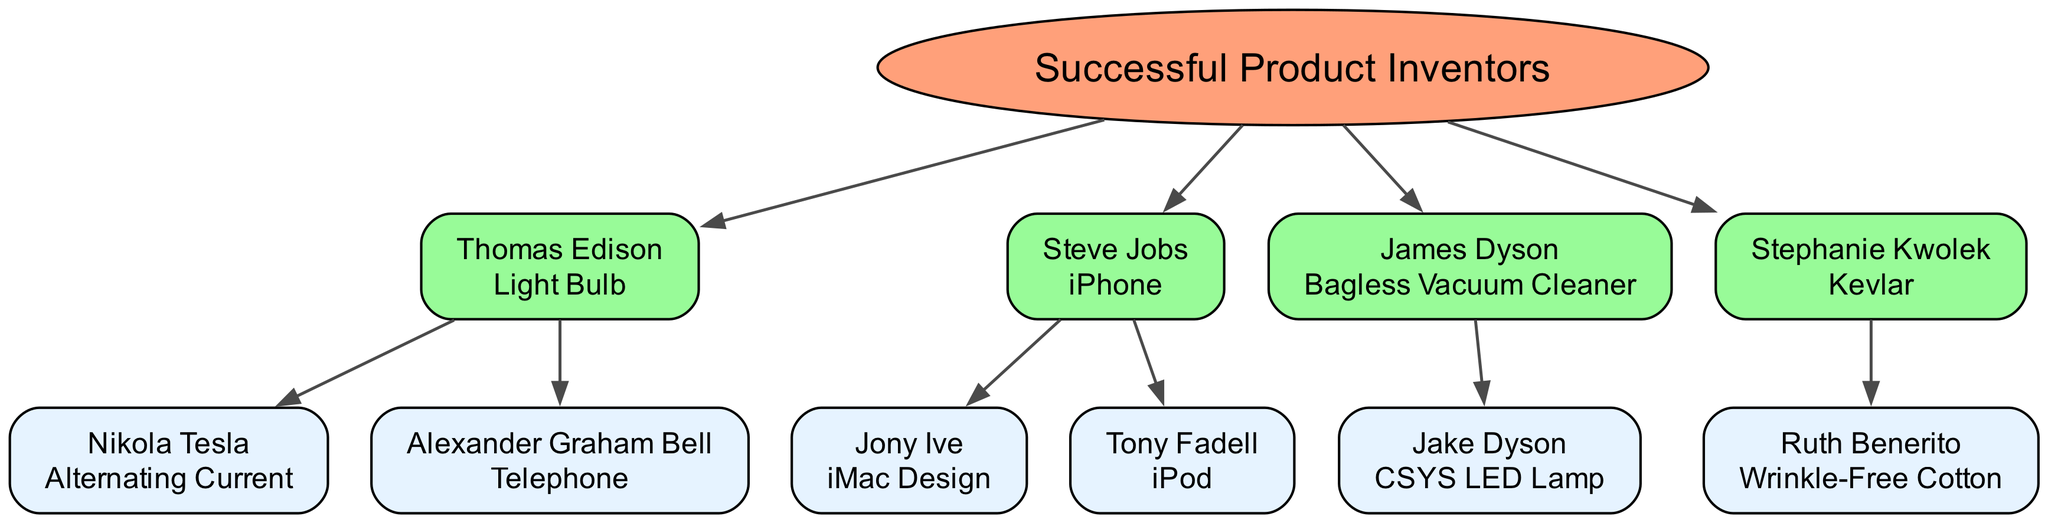What is the innovation associated with Thomas Edison? The diagram indicates that Thomas Edison's innovation is the Light Bulb, as it is listed next to his name.
Answer: Light Bulb Who are the children of Steve Jobs? The diagram displays two children under Steve Jobs: Jony Ive and Tony Fadell, both of whom contributed to design and product innovation related to Apple.
Answer: Jony Ive, Tony Fadell How many children does James Dyson have in the diagram? Upon examining the diagram, it is clear that James Dyson has one child listed under him, which is Jake Dyson.
Answer: 1 What is the relationship between Nikola Tesla and Thomas Edison? The diagram clarifies that Nikola Tesla is a direct child of Thomas Edison, indicating a familial and professional connection in innovating electrical products.
Answer: Child Which innovation is attributed to Jake Dyson? The diagram states that Jake Dyson's innovation is the CSYS LED Lamp, positioned beneath his name in the family tree.
Answer: CSYS LED Lamp How many total innovations are listed in the diagram? By counting all the unique innovations associated with each inventor and their children present in the diagram, the total comes to five distinct innovations.
Answer: 5 Which inventor is related to both Alexander Graham Bell and Thomas Edison? The diagram shows that both Alexander Graham Bell and Nikola Tesla are children of Thomas Edison, highlighting a lineage of innovation in communication and electrical technology.
Answer: Alexander Graham Bell What color represents the root node in the diagram? The diagram uses a distinctive fill color of light salmon (#FFA07A) for the root node, differentiating it from the other nodes.
Answer: #FFA07A Which innovation is Stephanie Kwolek known for? The diagram notes that Stephanie Kwolek is known for the innovation of Kevlar, positioned next to her name.
Answer: Kevlar 